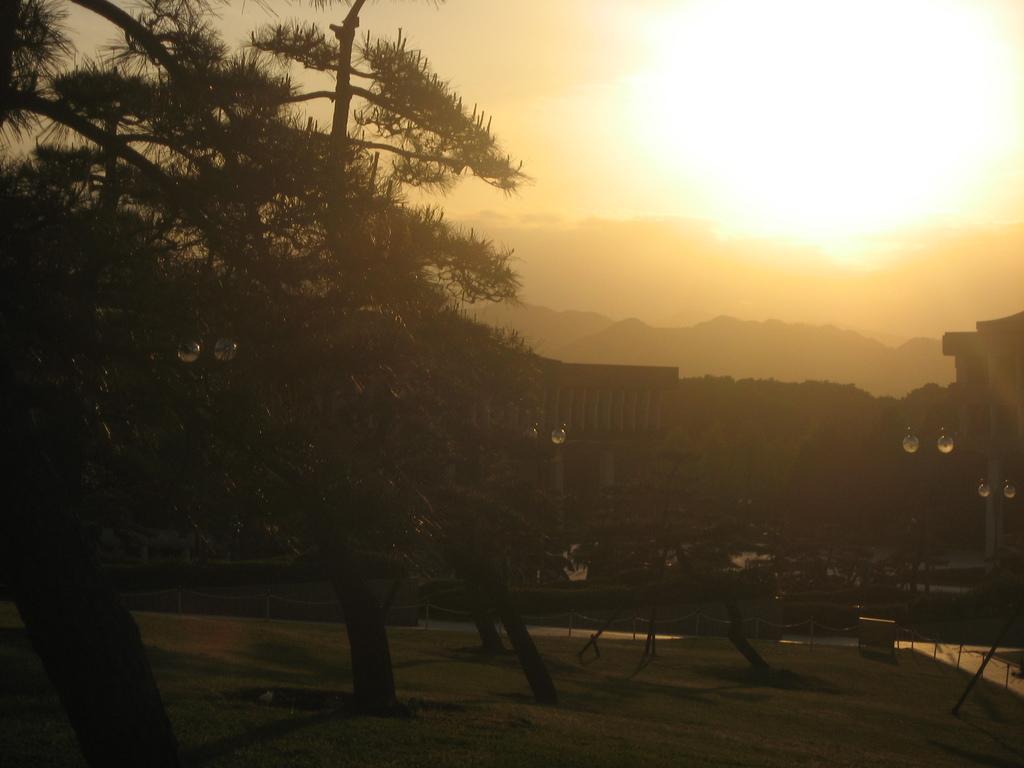How would you summarize this image in a sentence or two? In the foreground of the picture we can see trees, grass, water body and other objects. In the middle of the picture we can see buildings, trees and hills. At the top we can see sun shining in the sky. 